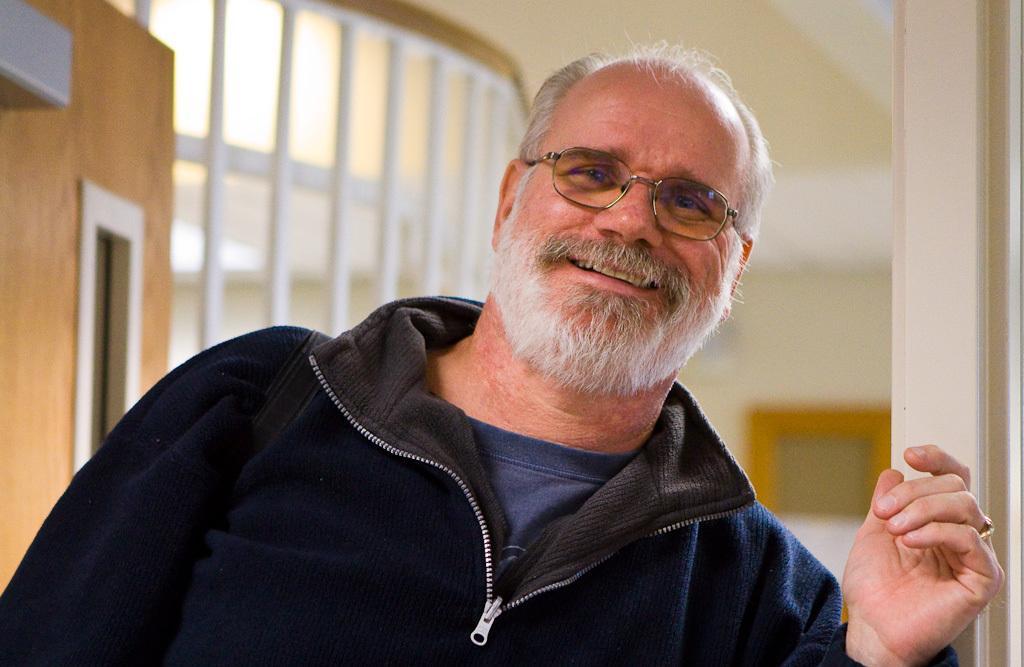In one or two sentences, can you explain what this image depicts? This picture shows the inner view of a building. In this image we can see one man sitting near to the door and some objects on the surface. 